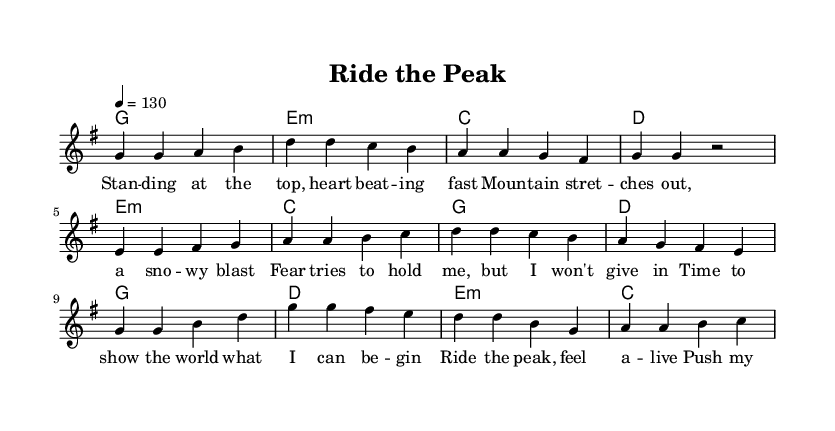What is the key signature of this music? The key signature is G major, which has one sharp (F#). You can determine this by looking at the beginning of the piece where the key is indicated.
Answer: G major What is the time signature of this music? The time signature is 4/4, which means there are four beats in each measure and the quarter note receives one beat. This is indicated right after the key signature at the start of the music.
Answer: 4/4 What is the tempo marking of this piece? The tempo is marked as 130 beats per minute. This information is provided at the beginning of the sheet music where the tempo marking is specified.
Answer: 130 How many measures are in the verse section? The verse section contains 4 measures. By counting the groups of notes divided by vertical lines (measure lines), you can tally the number of measures present in the verse section.
Answer: 4 Which chords are used in the pre-chorus? The pre-chorus consists of the chords E minor, C, G, and D. You can identify these chords by looking at the chord symbols written above the corresponding measures in the pre-chorus section.
Answer: E minor, C, G, D What thematic element does the title "Ride the Peak" suggest? The title suggests themes of aspiration and overcoming obstacles, indicative of the upbeat pop-rock genre which often celebrates perseverance amidst challenges. This is inferred from the words and spirit conveyed by the lyrics and overall music theme.
Answer: Aspiration and overcoming obstacles 